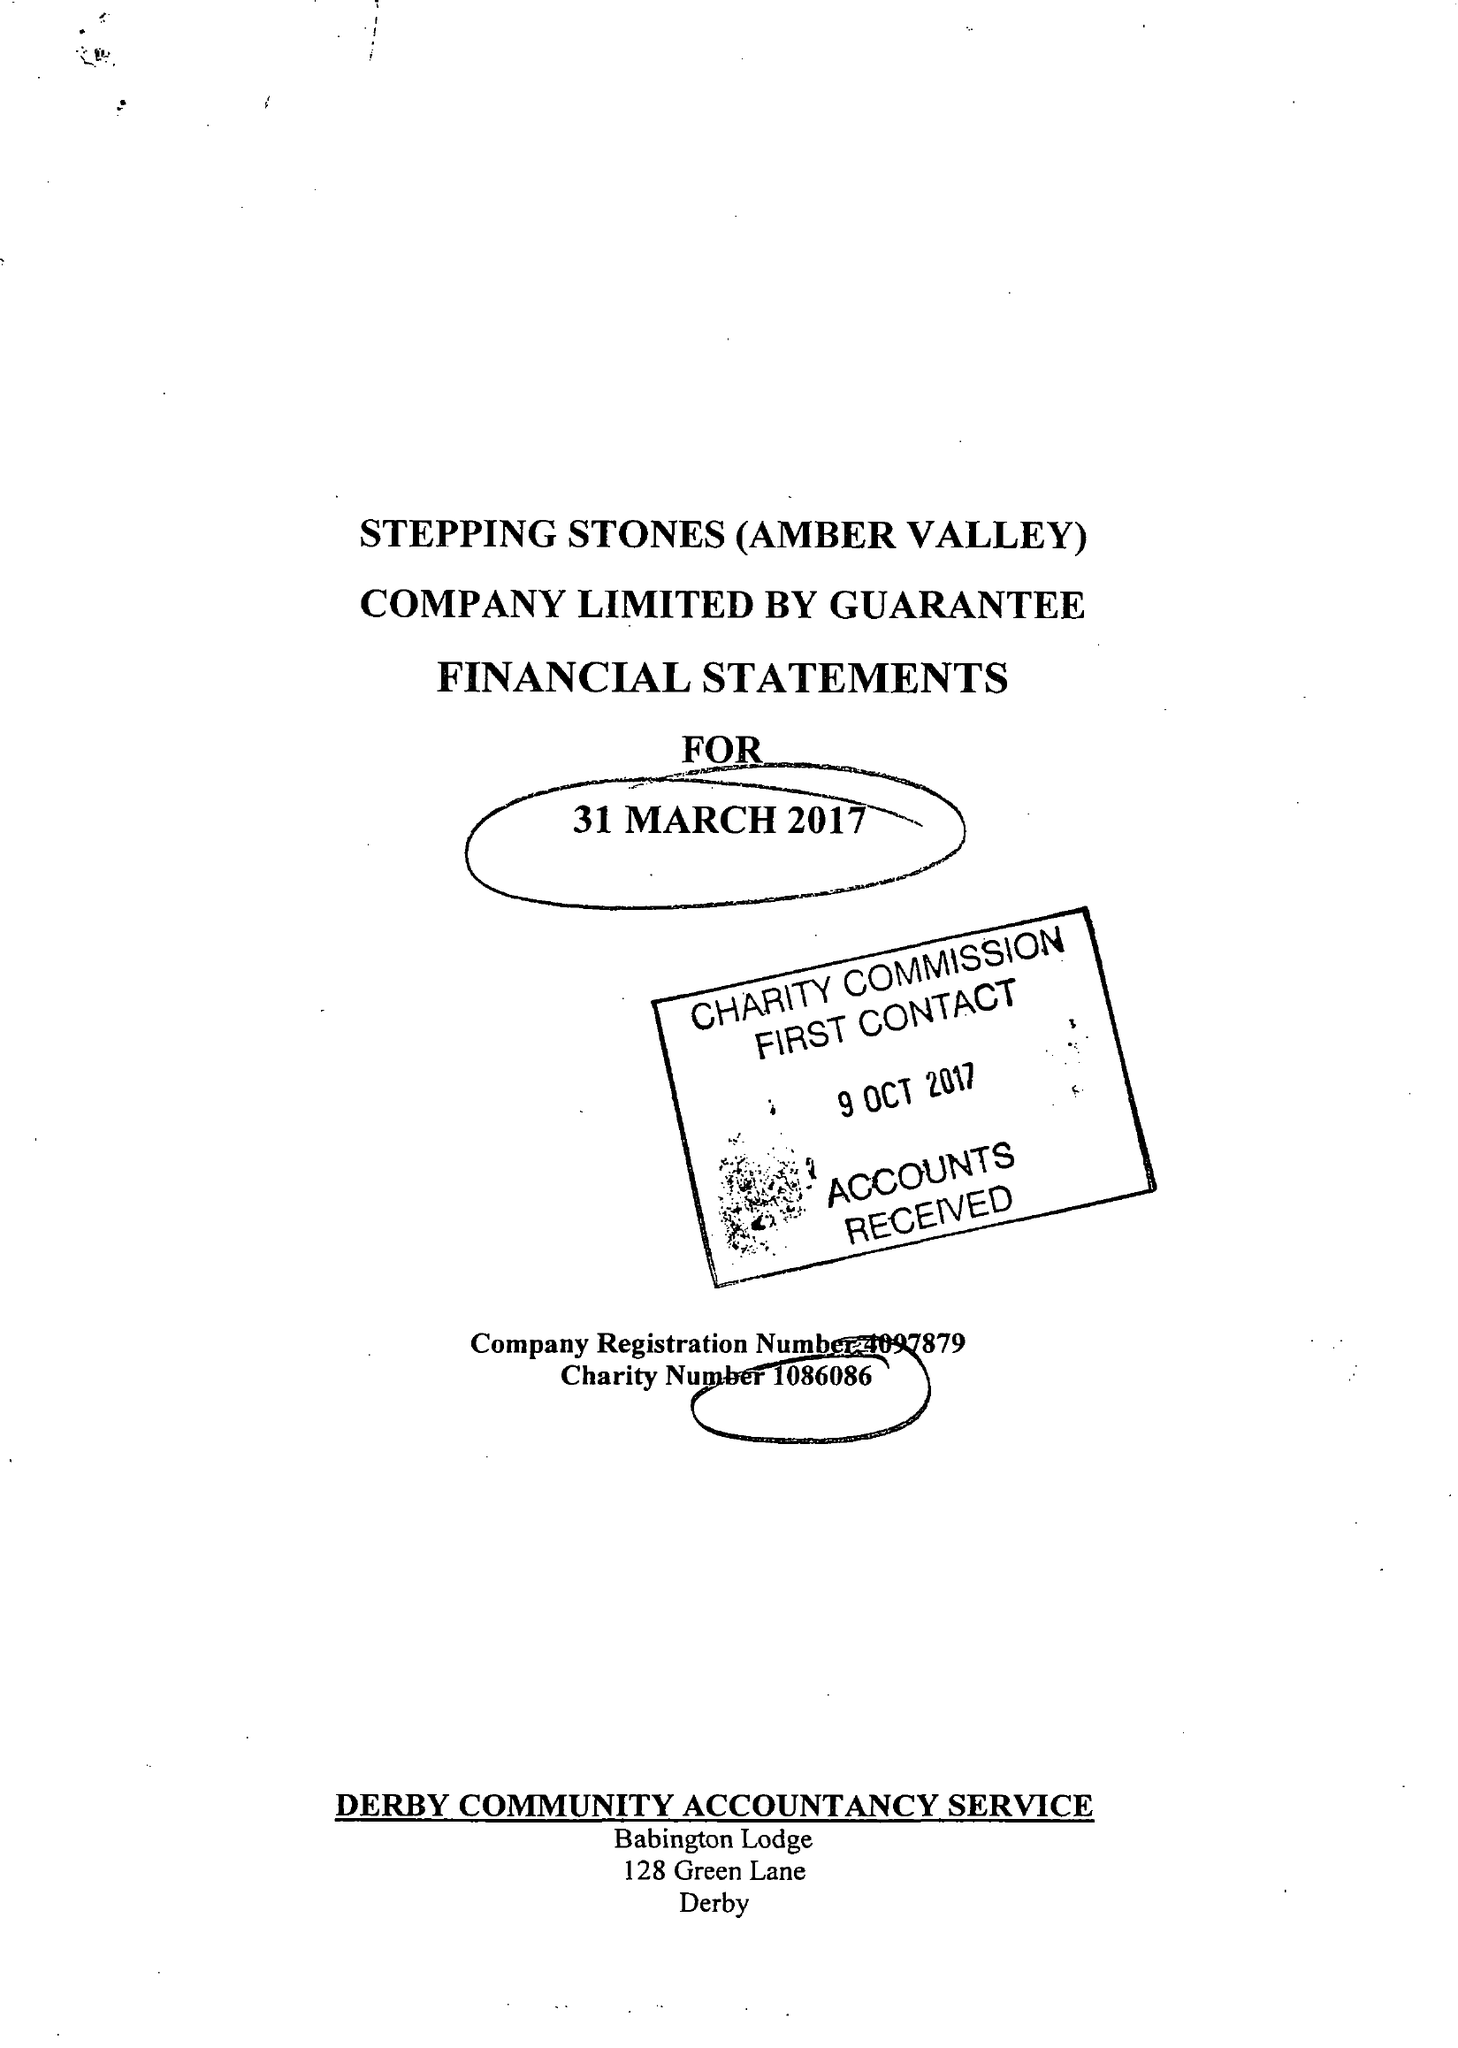What is the value for the income_annually_in_british_pounds?
Answer the question using a single word or phrase. 119817.00 